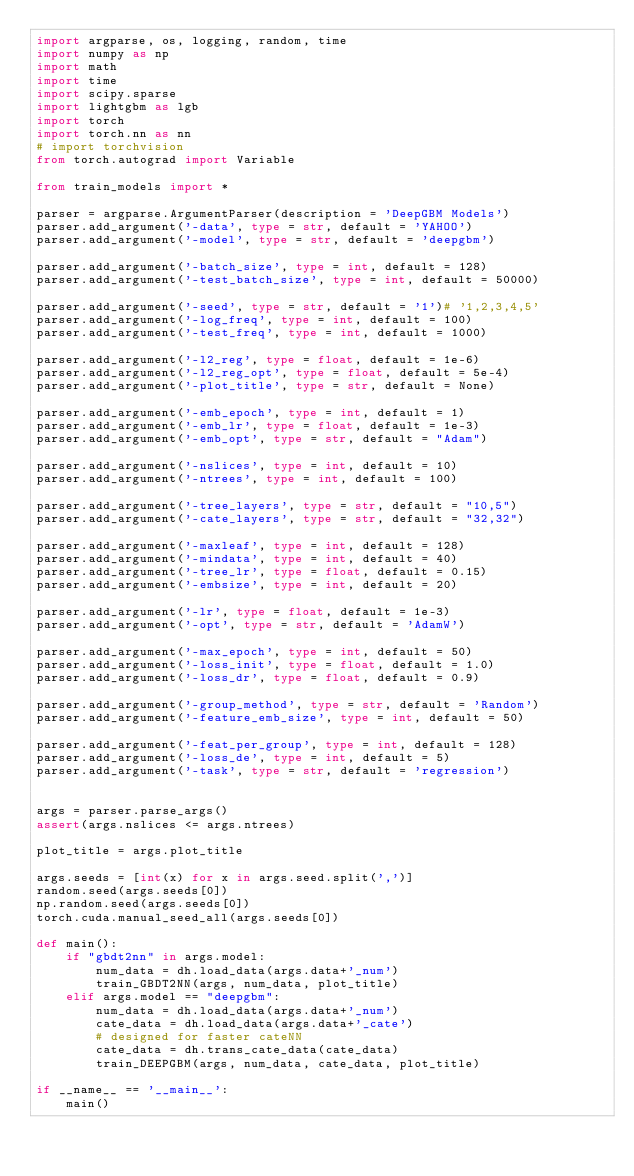Convert code to text. <code><loc_0><loc_0><loc_500><loc_500><_Python_>import argparse, os, logging, random, time
import numpy as np
import math
import time
import scipy.sparse
import lightgbm as lgb
import torch
import torch.nn as nn
# import torchvision
from torch.autograd import Variable

from train_models import *

parser = argparse.ArgumentParser(description = 'DeepGBM Models')
parser.add_argument('-data', type = str, default = 'YAHOO')
parser.add_argument('-model', type = str, default = 'deepgbm')

parser.add_argument('-batch_size', type = int, default = 128)
parser.add_argument('-test_batch_size', type = int, default = 50000)

parser.add_argument('-seed', type = str, default = '1')# '1,2,3,4,5'
parser.add_argument('-log_freq', type = int, default = 100)
parser.add_argument('-test_freq', type = int, default = 1000)

parser.add_argument('-l2_reg', type = float, default = 1e-6)
parser.add_argument('-l2_reg_opt', type = float, default = 5e-4)
parser.add_argument('-plot_title', type = str, default = None)

parser.add_argument('-emb_epoch', type = int, default = 1)
parser.add_argument('-emb_lr', type = float, default = 1e-3)
parser.add_argument('-emb_opt', type = str, default = "Adam")

parser.add_argument('-nslices', type = int, default = 10)
parser.add_argument('-ntrees', type = int, default = 100)

parser.add_argument('-tree_layers', type = str, default = "10,5")
parser.add_argument('-cate_layers', type = str, default = "32,32")

parser.add_argument('-maxleaf', type = int, default = 128)
parser.add_argument('-mindata', type = int, default = 40)
parser.add_argument('-tree_lr', type = float, default = 0.15)
parser.add_argument('-embsize', type = int, default = 20)

parser.add_argument('-lr', type = float, default = 1e-3)
parser.add_argument('-opt', type = str, default = 'AdamW')

parser.add_argument('-max_epoch', type = int, default = 50)
parser.add_argument('-loss_init', type = float, default = 1.0)
parser.add_argument('-loss_dr', type = float, default = 0.9)

parser.add_argument('-group_method', type = str, default = 'Random')
parser.add_argument('-feature_emb_size', type = int, default = 50)

parser.add_argument('-feat_per_group', type = int, default = 128)
parser.add_argument('-loss_de', type = int, default = 5)
parser.add_argument('-task', type = str, default = 'regression')


args = parser.parse_args()
assert(args.nslices <= args.ntrees)

plot_title = args.plot_title

args.seeds = [int(x) for x in args.seed.split(',')]
random.seed(args.seeds[0])
np.random.seed(args.seeds[0])
torch.cuda.manual_seed_all(args.seeds[0])
    
def main():
    if "gbdt2nn" in args.model:
        num_data = dh.load_data(args.data+'_num')
        train_GBDT2NN(args, num_data, plot_title)
    elif args.model == "deepgbm":
        num_data = dh.load_data(args.data+'_num')
        cate_data = dh.load_data(args.data+'_cate')
        # designed for faster cateNN
        cate_data = dh.trans_cate_data(cate_data)
        train_DEEPGBM(args, num_data, cate_data, plot_title)
    
if __name__ == '__main__':
    main()
</code> 